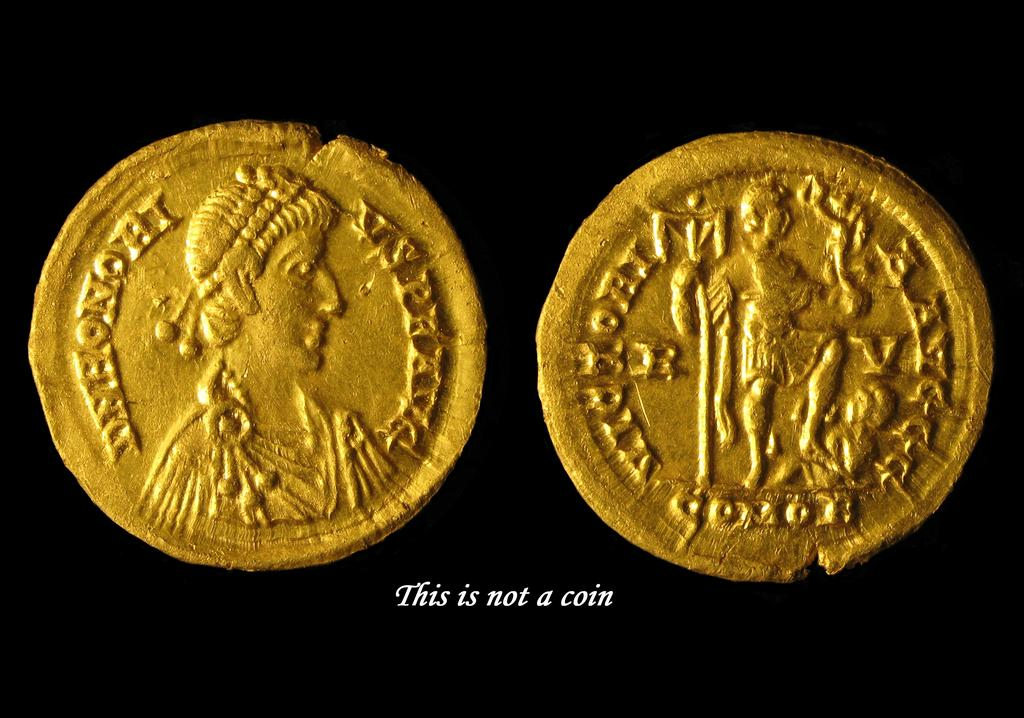<image>
Render a clear and concise summary of the photo. A label says "this is not a coin" under what clearly looks like a coin. 